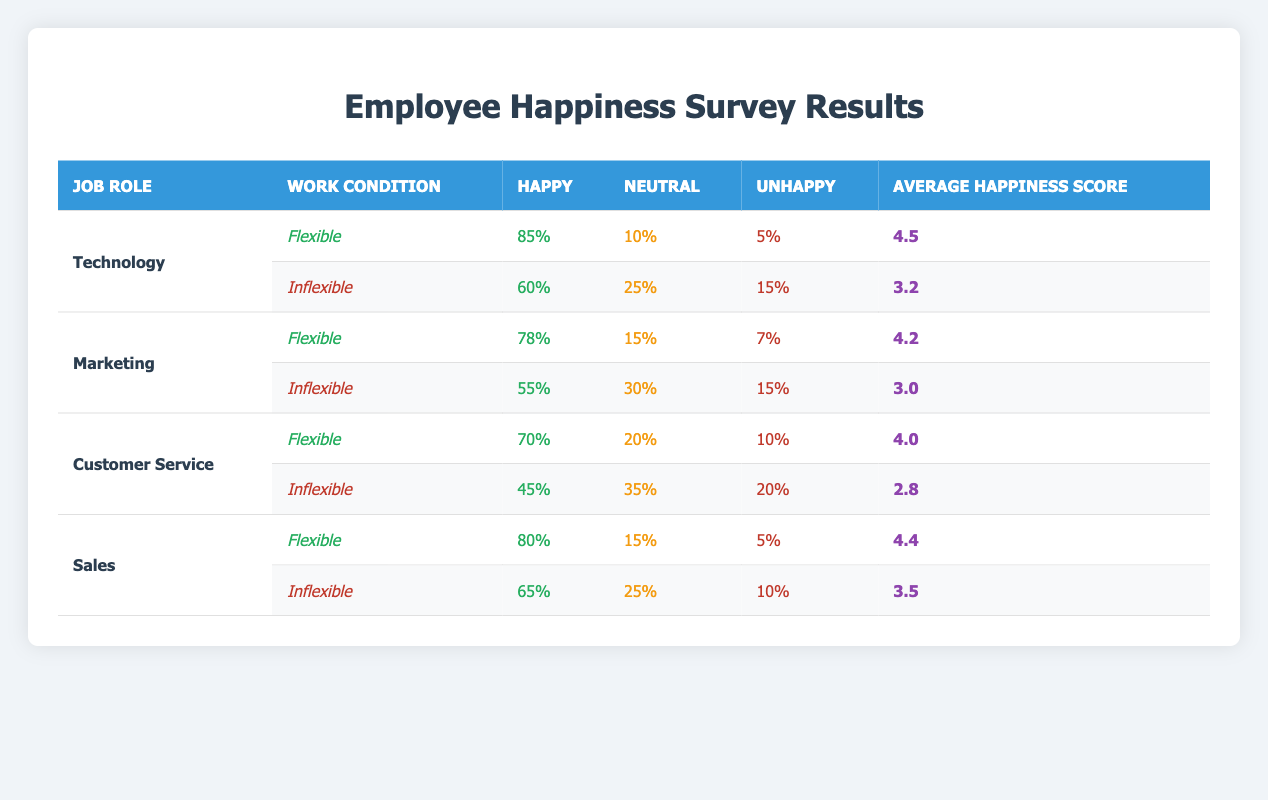What is the average happiness score for employees in Technology with flexible work conditions? The table shows that the average happiness score for Technology with flexible work conditions is 4.5. This value is found directly in the respective row for Technology and Flexible.
Answer: 4.5 How many employees in Customer Service reported feeling happy under inflexible conditions? According to the table, 45% of Customer Service employees reported feeling happy under inflexible conditions. This percentage is directly accessible from the appropriate row in the table.
Answer: 45% Which job role has the highest percentage of happiness under flexible conditions? Examining the table, Technology has the highest percentage of happiness under flexible conditions at 85%. This is determined by comparing the happiness percentages across all job roles listed under flexible conditions.
Answer: Technology What is the overall happiness percentage increase for Marketing employees when moving from inflexible to flexible work conditions? The happiness percentage for Marketing employees under flexible conditions is 78%, while under inflexible conditions it is 55%. The increase is calculated by subtracting the inflexible percentage from the flexible percentage: 78% - 55% = 23%.
Answer: 23% Is it true that employees in Customer Service feel happier under flexible conditions compared to those in Sales under inflexible conditions? Yes, it is true. Customer Service employees have a happiness percentage of 70% under flexible conditions, while Sales employees have a happiness percentage of 65% under inflexible conditions. This comparison confirms that Customer Service employees are indeed happier in this scenario.
Answer: Yes What is the difference in the average happiness score between flexible and inflexible conditions for the Sales role? For Sales, the average happiness score is 4.4 under flexible conditions and 3.5 under inflexible conditions. The difference can be calculated as 4.4 - 3.5 = 0.9. This shows that there is a positive change in happiness with the flexible arrangement.
Answer: 0.9 How many employees in Marketing reported being unhappy under flexible work conditions? The table indicates that 7% of Marketing employees reported being unhappy under flexible work conditions. This value is stated directly in the respective row of the table.
Answer: 7% In which job role does the gap between happy and unhappy employees widen the most when switching from inflexible to flexible conditions? By analyzing the data, Marketing shows a notable change from 55% happy and 15% unhappy inflexible to 78% happy and 7% unhappy flexible. The gap increased from 40% to 71%, making a widening gap of 31%. This is the largest change across the roles.
Answer: Marketing 